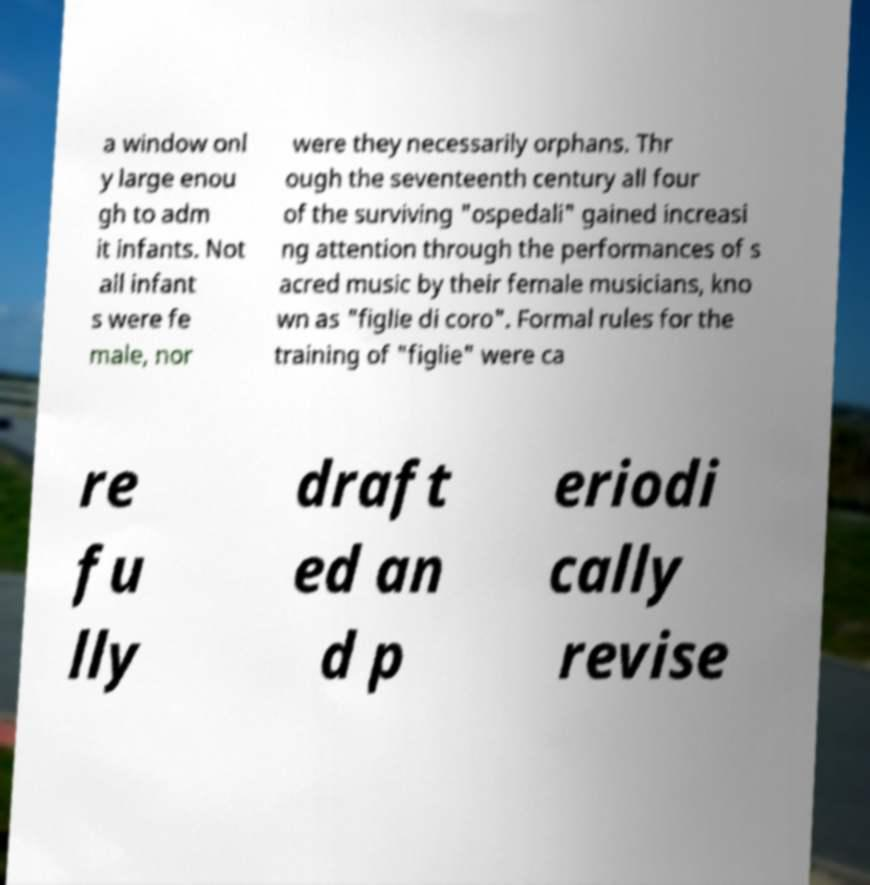Can you accurately transcribe the text from the provided image for me? a window onl y large enou gh to adm it infants. Not all infant s were fe male, nor were they necessarily orphans. Thr ough the seventeenth century all four of the surviving "ospedali" gained increasi ng attention through the performances of s acred music by their female musicians, kno wn as "figlie di coro". Formal rules for the training of "figlie" were ca re fu lly draft ed an d p eriodi cally revise 